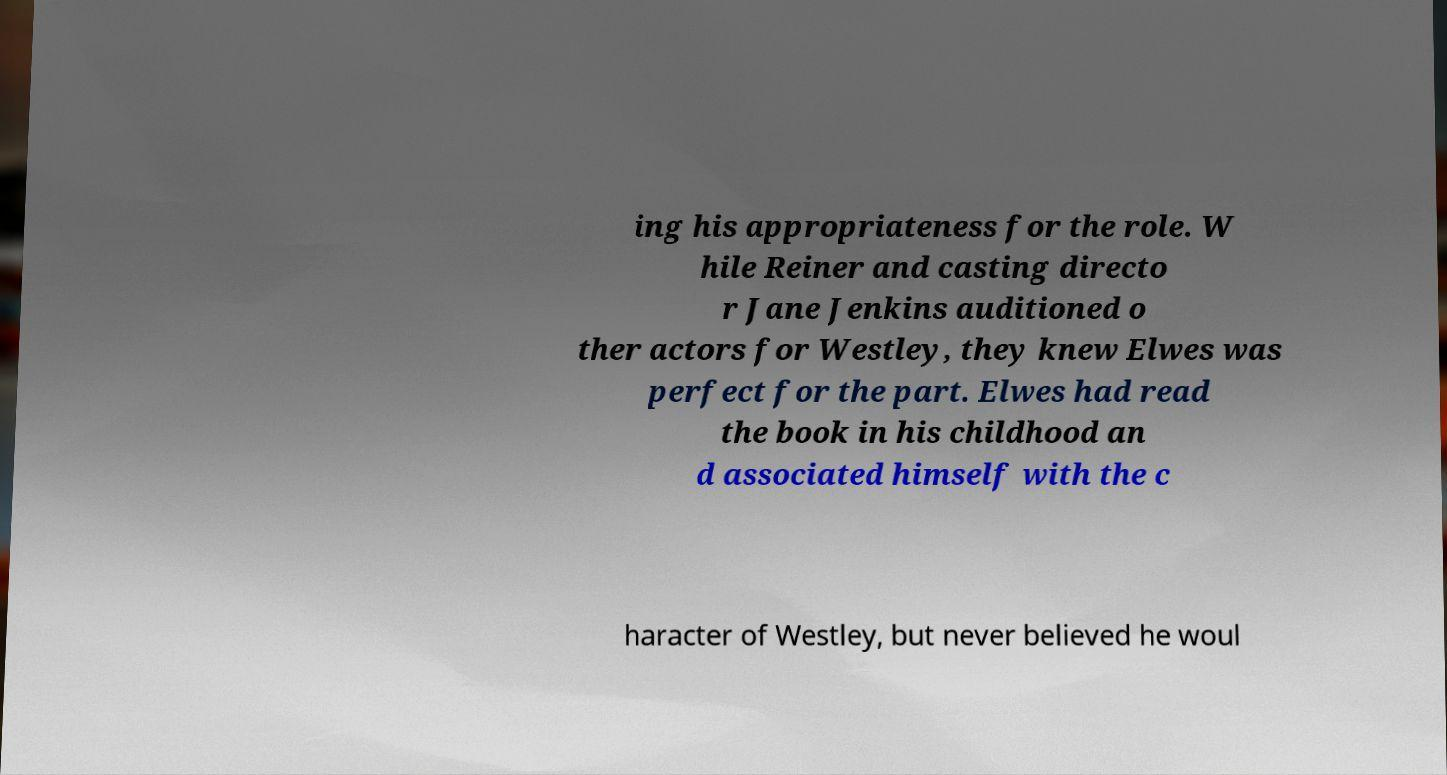I need the written content from this picture converted into text. Can you do that? ing his appropriateness for the role. W hile Reiner and casting directo r Jane Jenkins auditioned o ther actors for Westley, they knew Elwes was perfect for the part. Elwes had read the book in his childhood an d associated himself with the c haracter of Westley, but never believed he woul 